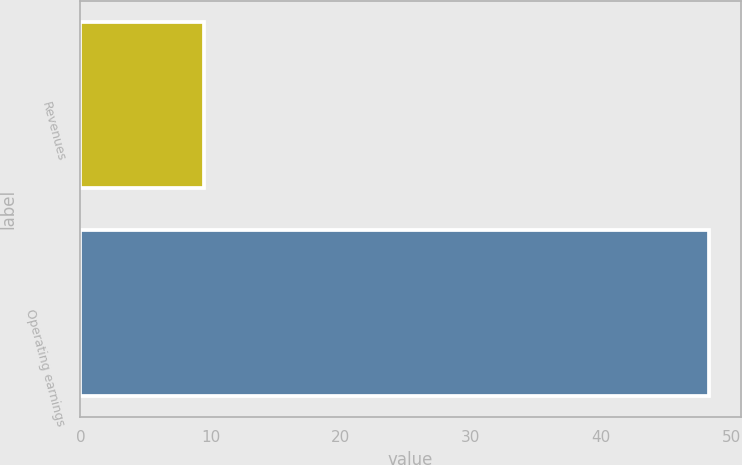Convert chart to OTSL. <chart><loc_0><loc_0><loc_500><loc_500><bar_chart><fcel>Revenues<fcel>Operating earnings<nl><fcel>9.5<fcel>48.3<nl></chart> 